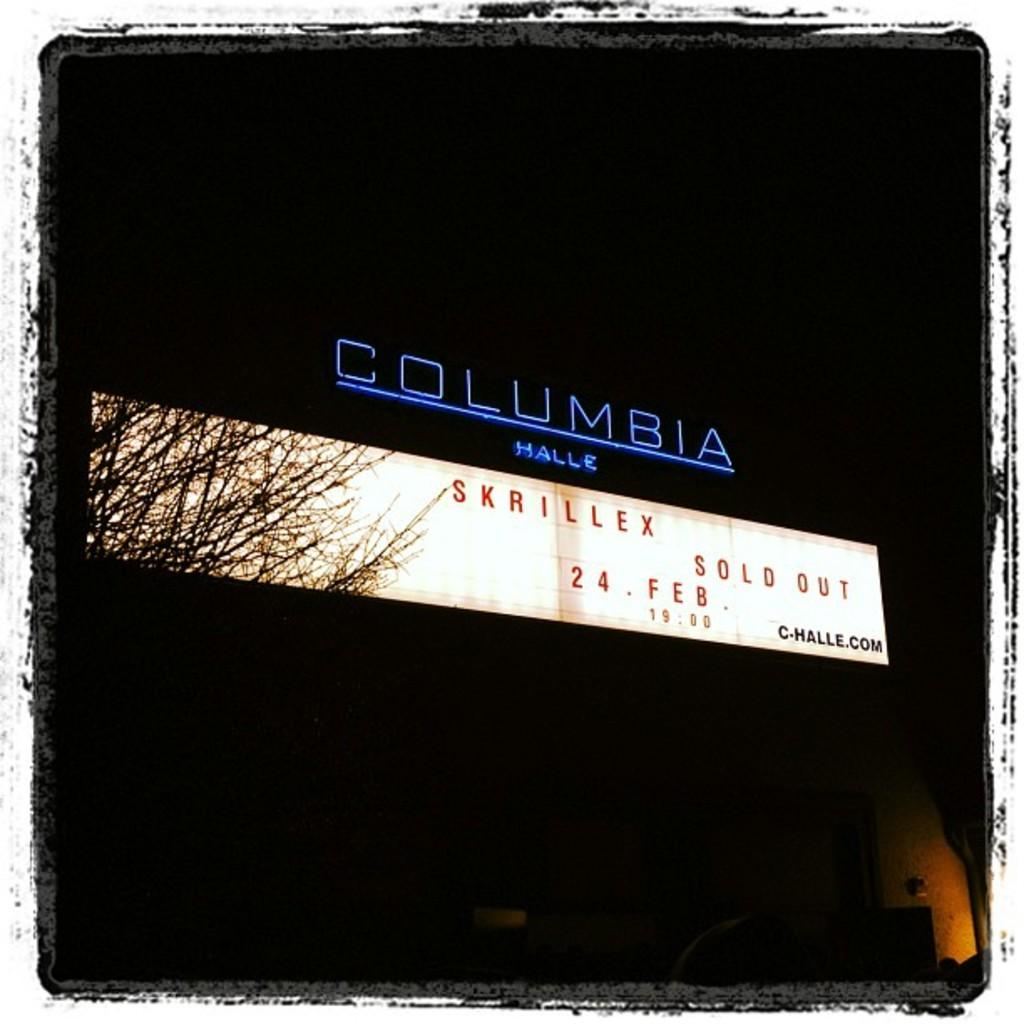What is the main object in the image? There is an LED board in the image. What is displayed on the LED board? There is text on the LED board. What other object can be seen in the image? There is a tree in the image. How would you describe the overall lighting in the image? The background of the image is dark. How many carpenters are working on the tree in the image? There are no carpenters present in the image, and the tree is not being worked on. What type of mist can be seen surrounding the LED board in the image? There is no mist present in the image; the background is simply dark. 